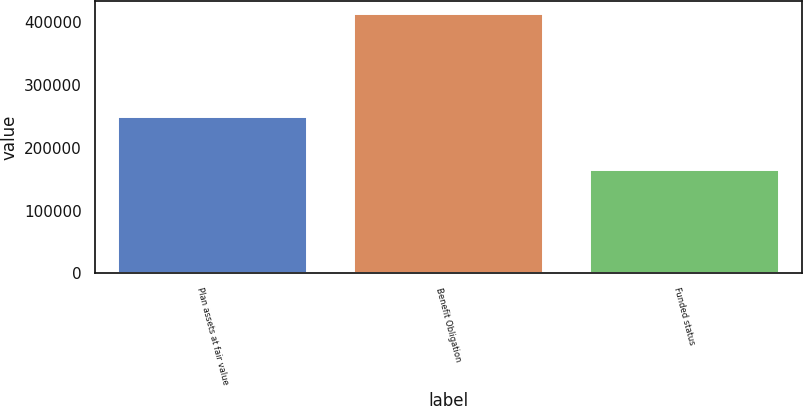Convert chart. <chart><loc_0><loc_0><loc_500><loc_500><bar_chart><fcel>Plan assets at fair value<fcel>Benefit Obligation<fcel>Funded status<nl><fcel>248733<fcel>413960<fcel>165227<nl></chart> 